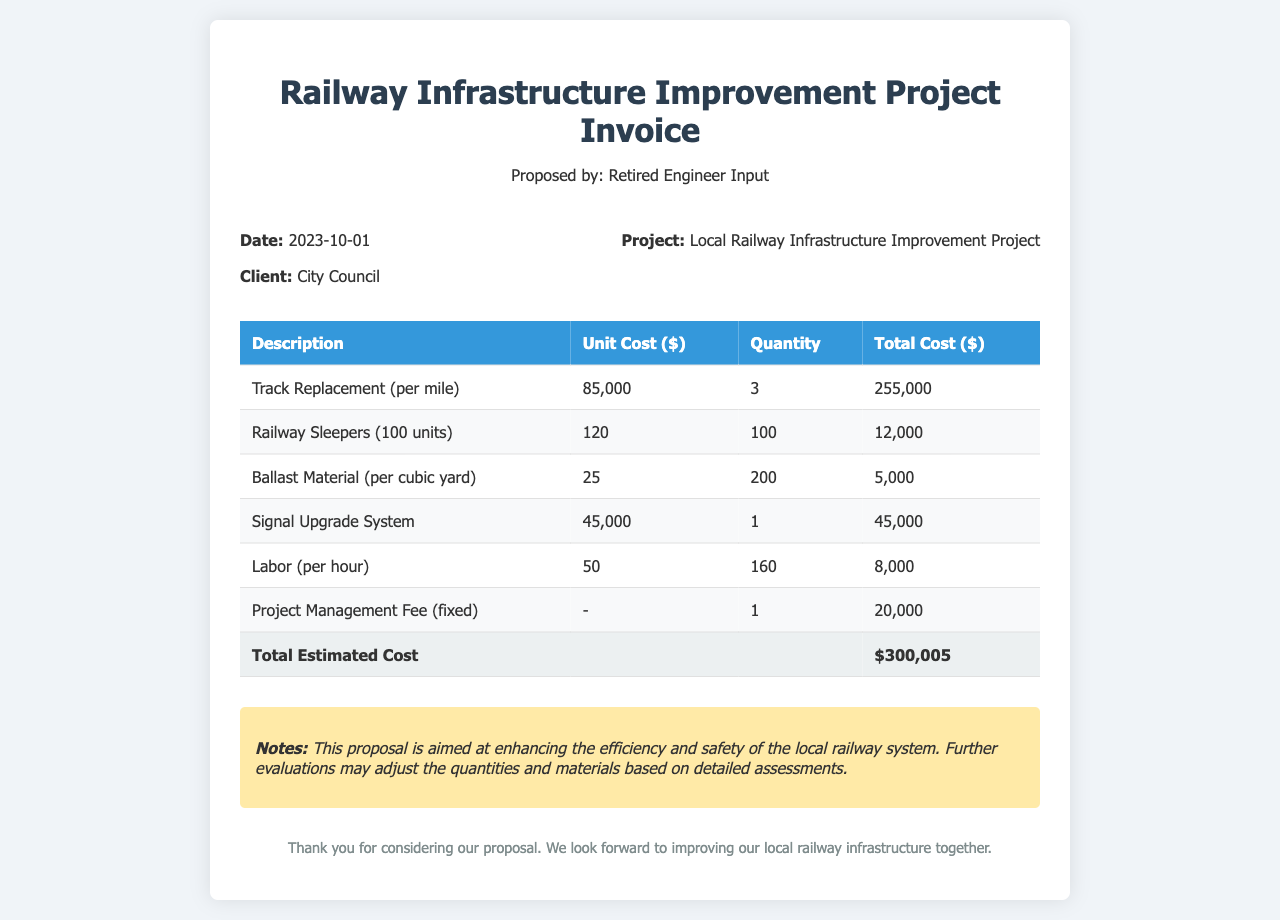What is the date of the invoice? The date of the invoice is clearly stated in the document as when the project proposal was presented.
Answer: 2023-10-01 Who is the client for this project? The client is mentioned in the sub-header of the invoice, identifying the entity responsible for the project.
Answer: City Council What is the unit cost of Track Replacement? The invoice specifies the cost per mile for Track Replacement directly in the cost table.
Answer: 85,000 How many units of Railway Sleepers are proposed? The quantity of Railway Sleepers is listed in the table under the respective item description.
Answer: 100 What is the total estimated cost of the project? The total estimated cost is calculated by summing all the individual costs listed in the invoice.
Answer: $300,005 What fixed fee is included for Project Management? The fixed fee for Project Management is outlined in the cost table.
Answer: 20,000 What material is specified for Ballast? The type of material for Ballast is referred to directly in the description column of the cost table.
Answer: Ballast Material What is the quantity of labor hours estimated? The total labor hours proposed for the project can be found in the quantity column of the labor entry.
Answer: 160 What is included in the notes section? The notes section provides further context regarding the purpose of the proposal and its expectations.
Answer: Enhancing efficiency and safety 